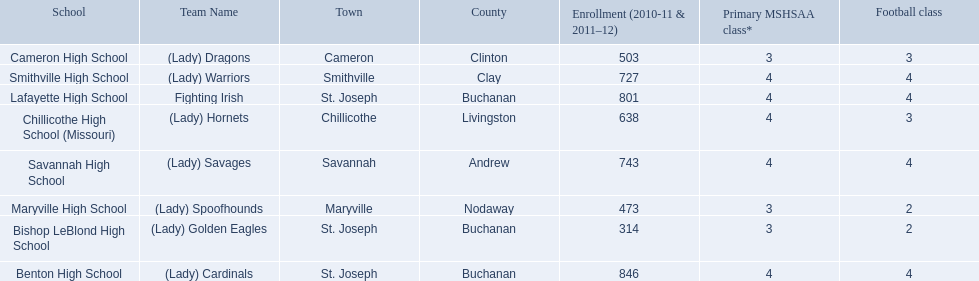What are the three schools in the town of st. joseph? St. Joseph, St. Joseph, St. Joseph. Of the three schools in st. joseph which school's team name does not depict a type of animal? Lafayette High School. 